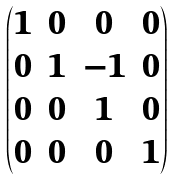<formula> <loc_0><loc_0><loc_500><loc_500>\begin{pmatrix} 1 & 0 & 0 & 0 \\ 0 & 1 & - 1 & 0 \\ 0 & 0 & 1 & 0 \\ 0 & 0 & 0 & 1 \end{pmatrix}</formula> 